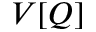<formula> <loc_0><loc_0><loc_500><loc_500>V [ Q ]</formula> 